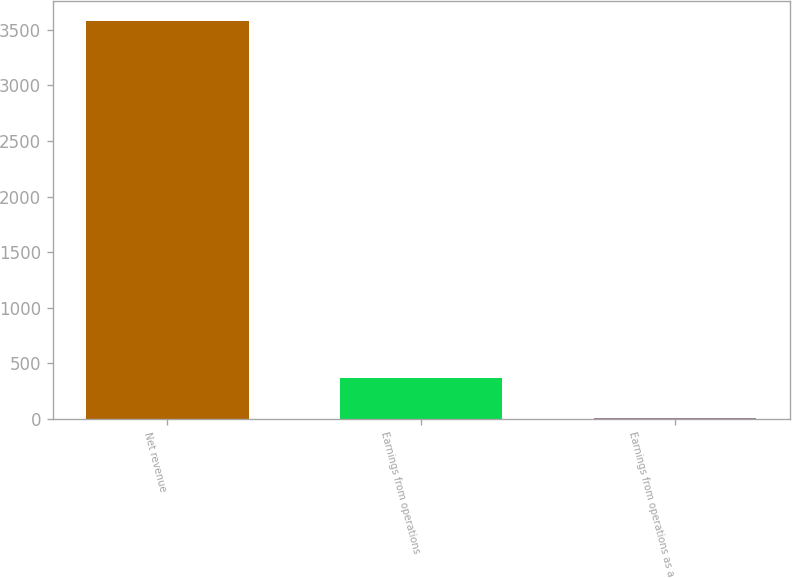Convert chart. <chart><loc_0><loc_0><loc_500><loc_500><bar_chart><fcel>Net revenue<fcel>Earnings from operations<fcel>Earnings from operations as a<nl><fcel>3581<fcel>365.75<fcel>8.5<nl></chart> 